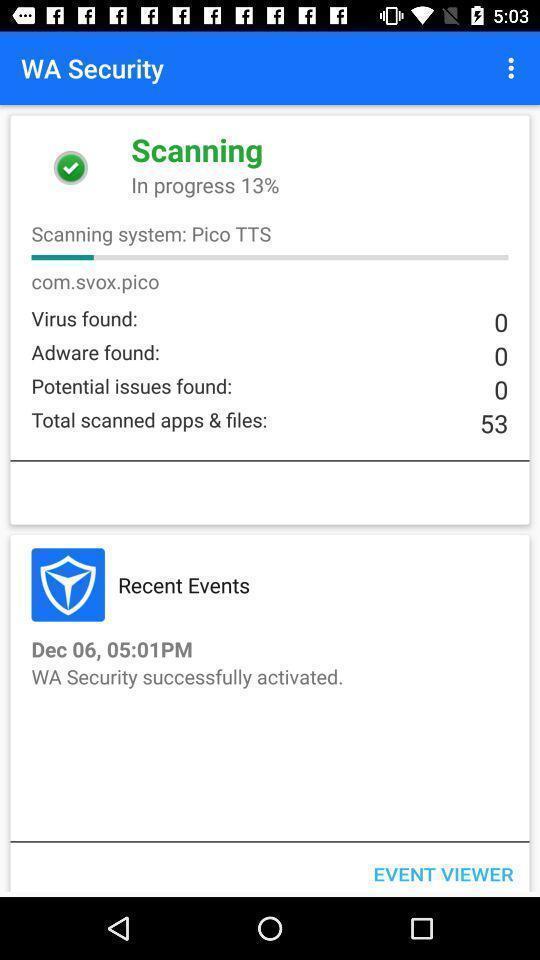Explain what's happening in this screen capture. Page displays scanning progress in app. 